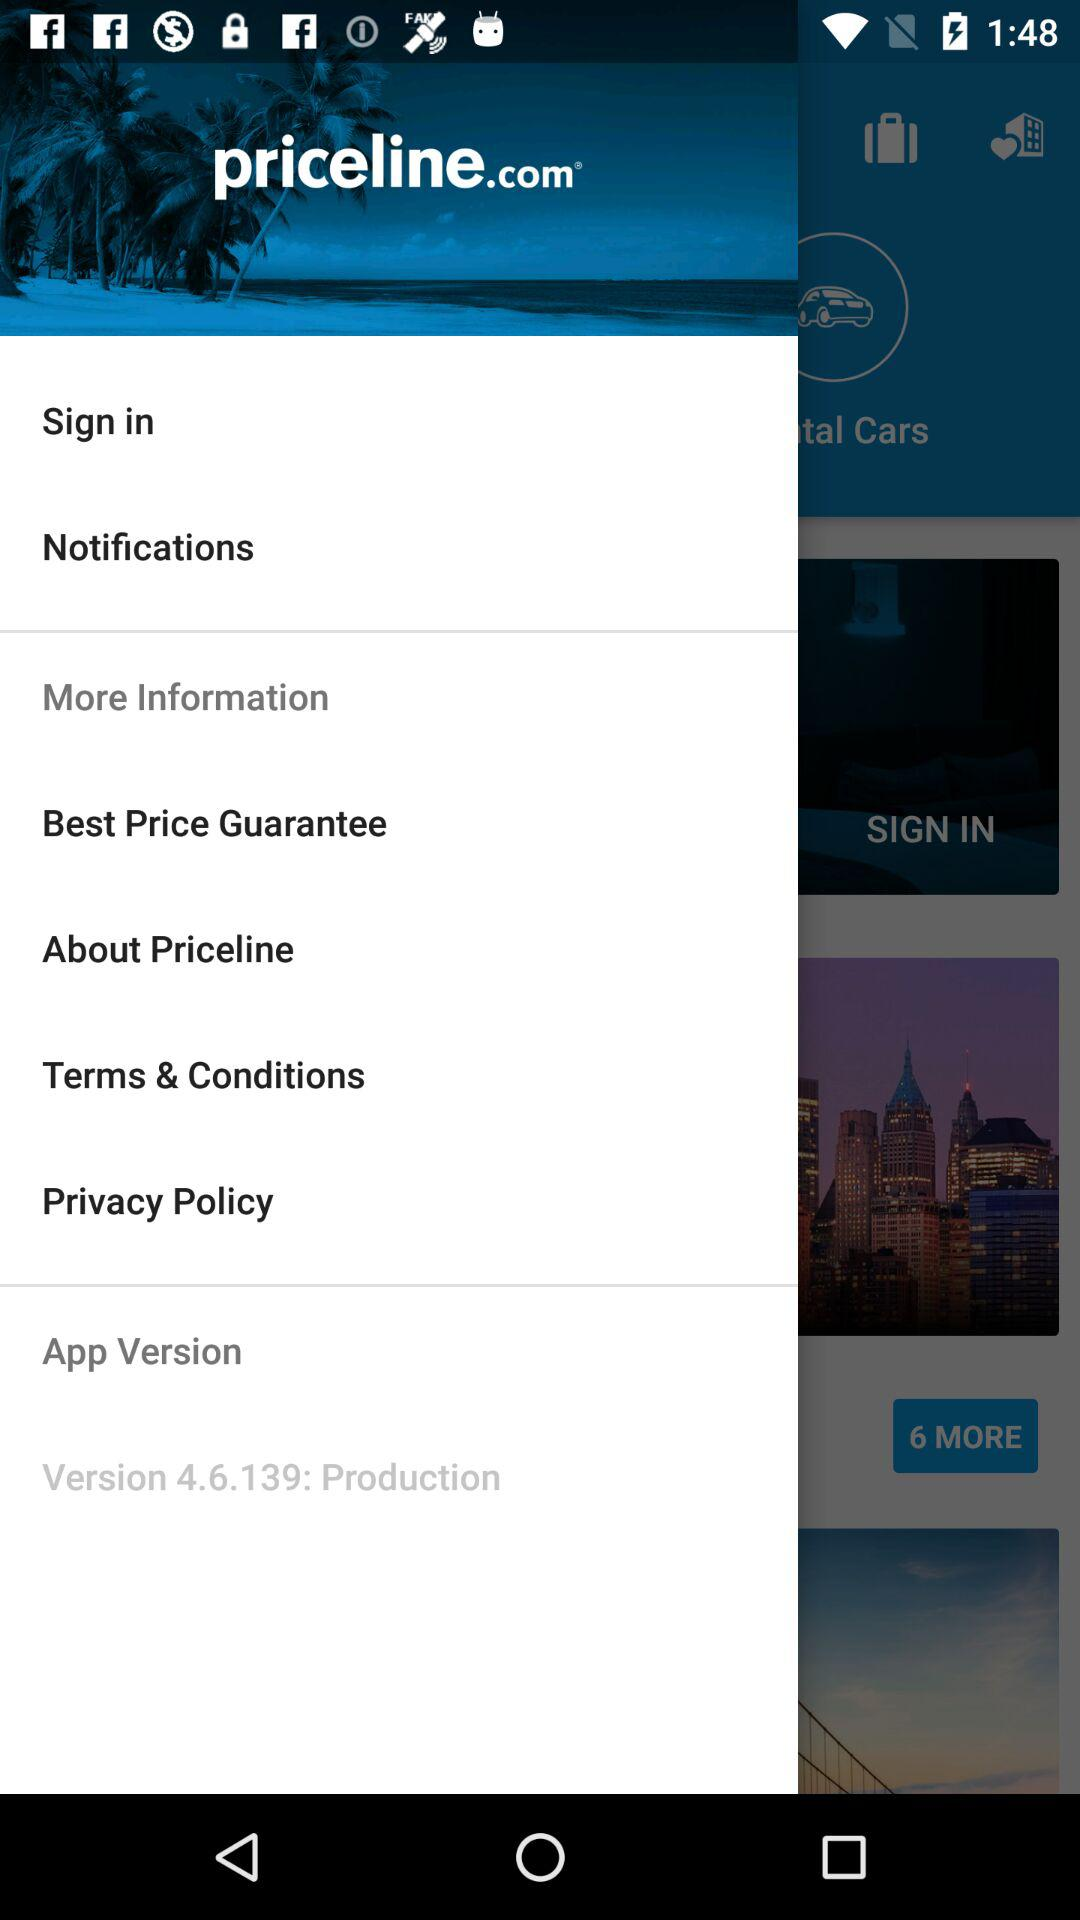What is the application name? The application name is "priceline.com". 